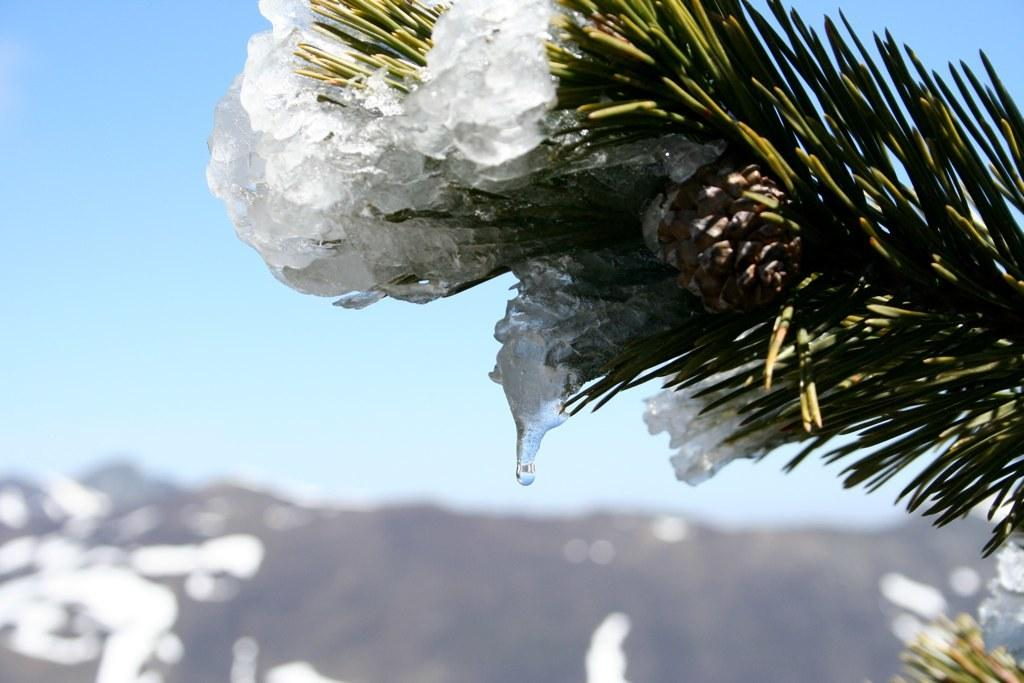What can be seen in the sky in the image? The sky is visible in the image. What type of natural formation is present in the image? There are mountains in the image. What type of vegetation is present in the image? There is a plant in the image. What type of weather condition is depicted in the image? There is snow in the image. What type of food is being advertised in the image? There is no food or advertisement present in the image. Can you tell me where the nearest store is located in the image? There is no store present in the image. 